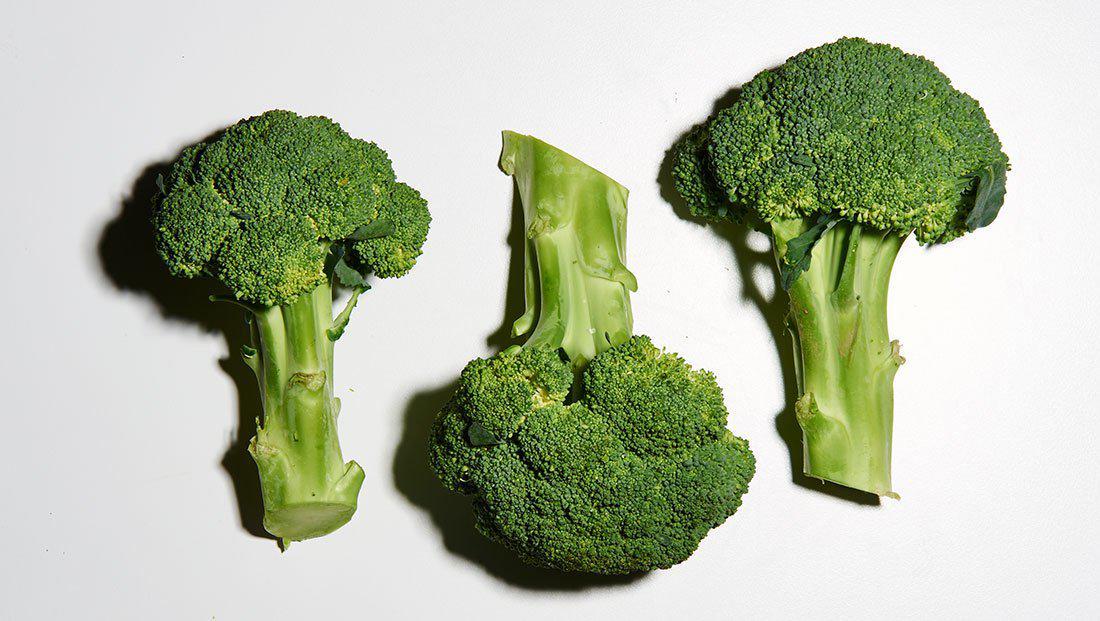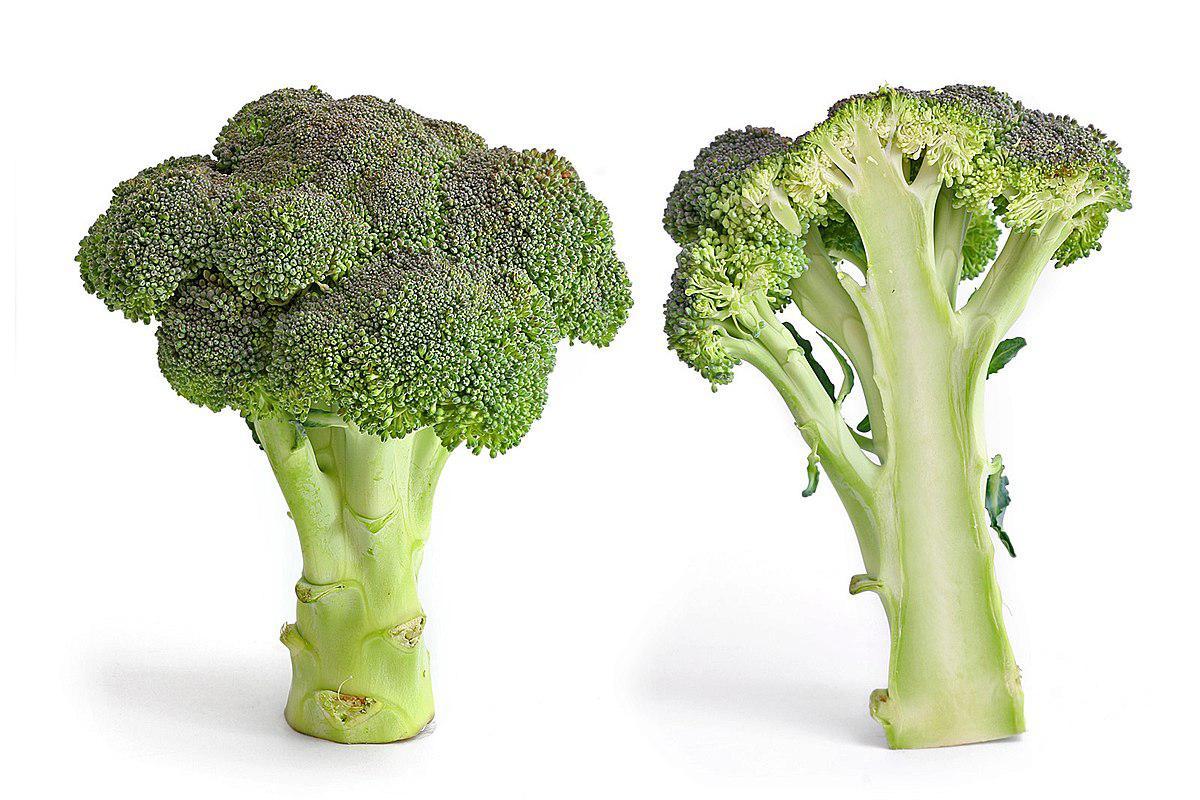The first image is the image on the left, the second image is the image on the right. Considering the images on both sides, is "Images show a total of five broccoli florets arranged horizontally." valid? Answer yes or no. Yes. 